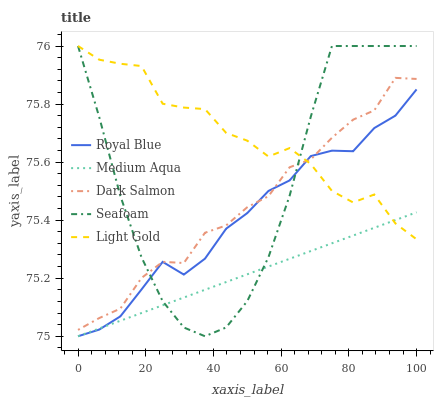Does Medium Aqua have the minimum area under the curve?
Answer yes or no. Yes. Does Light Gold have the maximum area under the curve?
Answer yes or no. Yes. Does Light Gold have the minimum area under the curve?
Answer yes or no. No. Does Medium Aqua have the maximum area under the curve?
Answer yes or no. No. Is Medium Aqua the smoothest?
Answer yes or no. Yes. Is Light Gold the roughest?
Answer yes or no. Yes. Is Light Gold the smoothest?
Answer yes or no. No. Is Medium Aqua the roughest?
Answer yes or no. No. Does Light Gold have the lowest value?
Answer yes or no. No. Does Medium Aqua have the highest value?
Answer yes or no. No. Is Medium Aqua less than Dark Salmon?
Answer yes or no. Yes. Is Dark Salmon greater than Medium Aqua?
Answer yes or no. Yes. Does Medium Aqua intersect Dark Salmon?
Answer yes or no. No. 